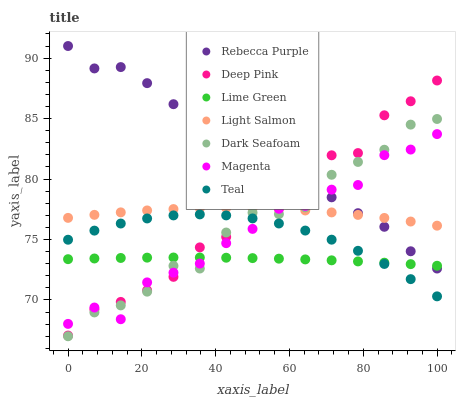Does Lime Green have the minimum area under the curve?
Answer yes or no. Yes. Does Rebecca Purple have the maximum area under the curve?
Answer yes or no. Yes. Does Deep Pink have the minimum area under the curve?
Answer yes or no. No. Does Deep Pink have the maximum area under the curve?
Answer yes or no. No. Is Lime Green the smoothest?
Answer yes or no. Yes. Is Magenta the roughest?
Answer yes or no. Yes. Is Deep Pink the smoothest?
Answer yes or no. No. Is Deep Pink the roughest?
Answer yes or no. No. Does Dark Seafoam have the lowest value?
Answer yes or no. Yes. Does Deep Pink have the lowest value?
Answer yes or no. No. Does Rebecca Purple have the highest value?
Answer yes or no. Yes. Does Deep Pink have the highest value?
Answer yes or no. No. Is Teal less than Light Salmon?
Answer yes or no. Yes. Is Light Salmon greater than Lime Green?
Answer yes or no. Yes. Does Magenta intersect Deep Pink?
Answer yes or no. Yes. Is Magenta less than Deep Pink?
Answer yes or no. No. Is Magenta greater than Deep Pink?
Answer yes or no. No. Does Teal intersect Light Salmon?
Answer yes or no. No. 